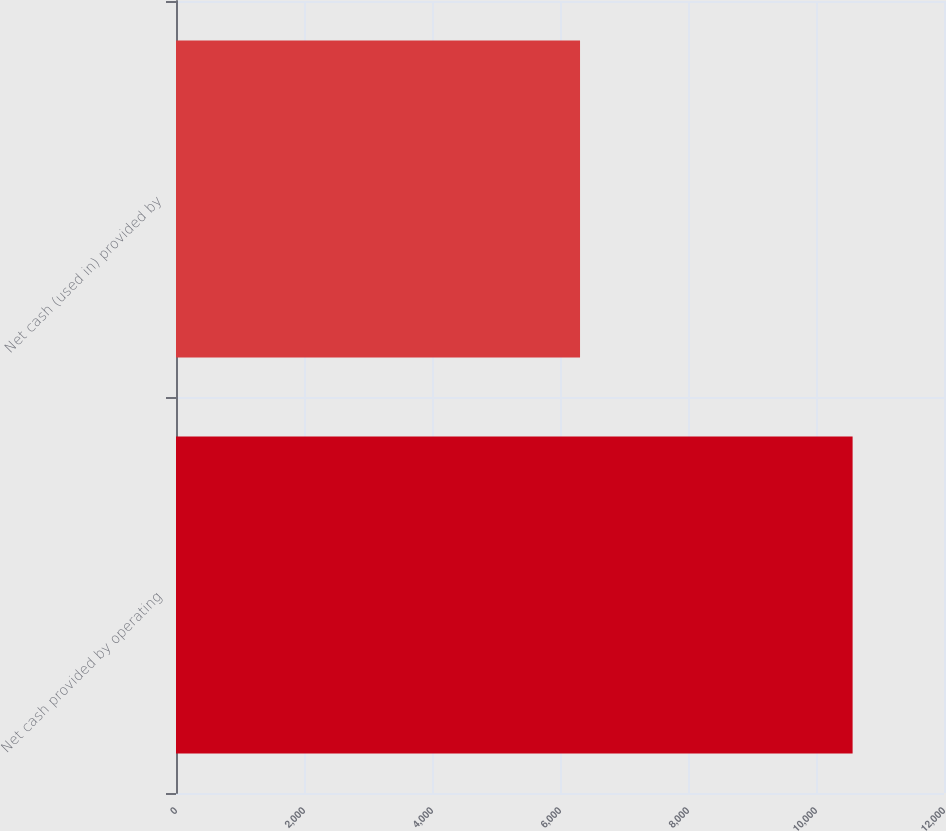Convert chart. <chart><loc_0><loc_0><loc_500><loc_500><bar_chart><fcel>Net cash provided by operating<fcel>Net cash (used in) provided by<nl><fcel>10572<fcel>6313<nl></chart> 